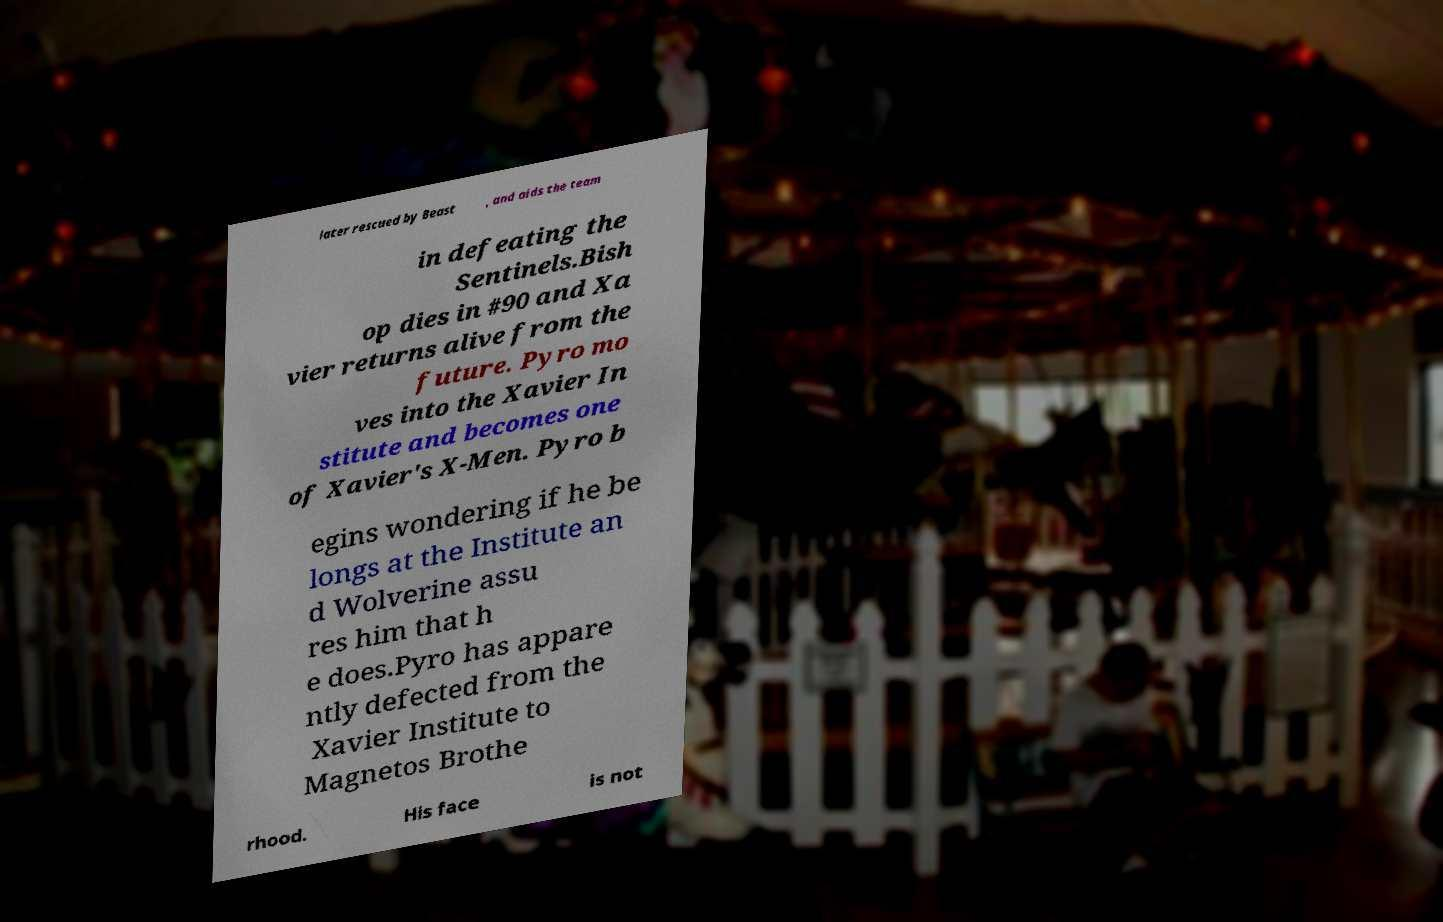There's text embedded in this image that I need extracted. Can you transcribe it verbatim? later rescued by Beast , and aids the team in defeating the Sentinels.Bish op dies in #90 and Xa vier returns alive from the future. Pyro mo ves into the Xavier In stitute and becomes one of Xavier's X-Men. Pyro b egins wondering if he be longs at the Institute an d Wolverine assu res him that h e does.Pyro has appare ntly defected from the Xavier Institute to Magnetos Brothe rhood. His face is not 